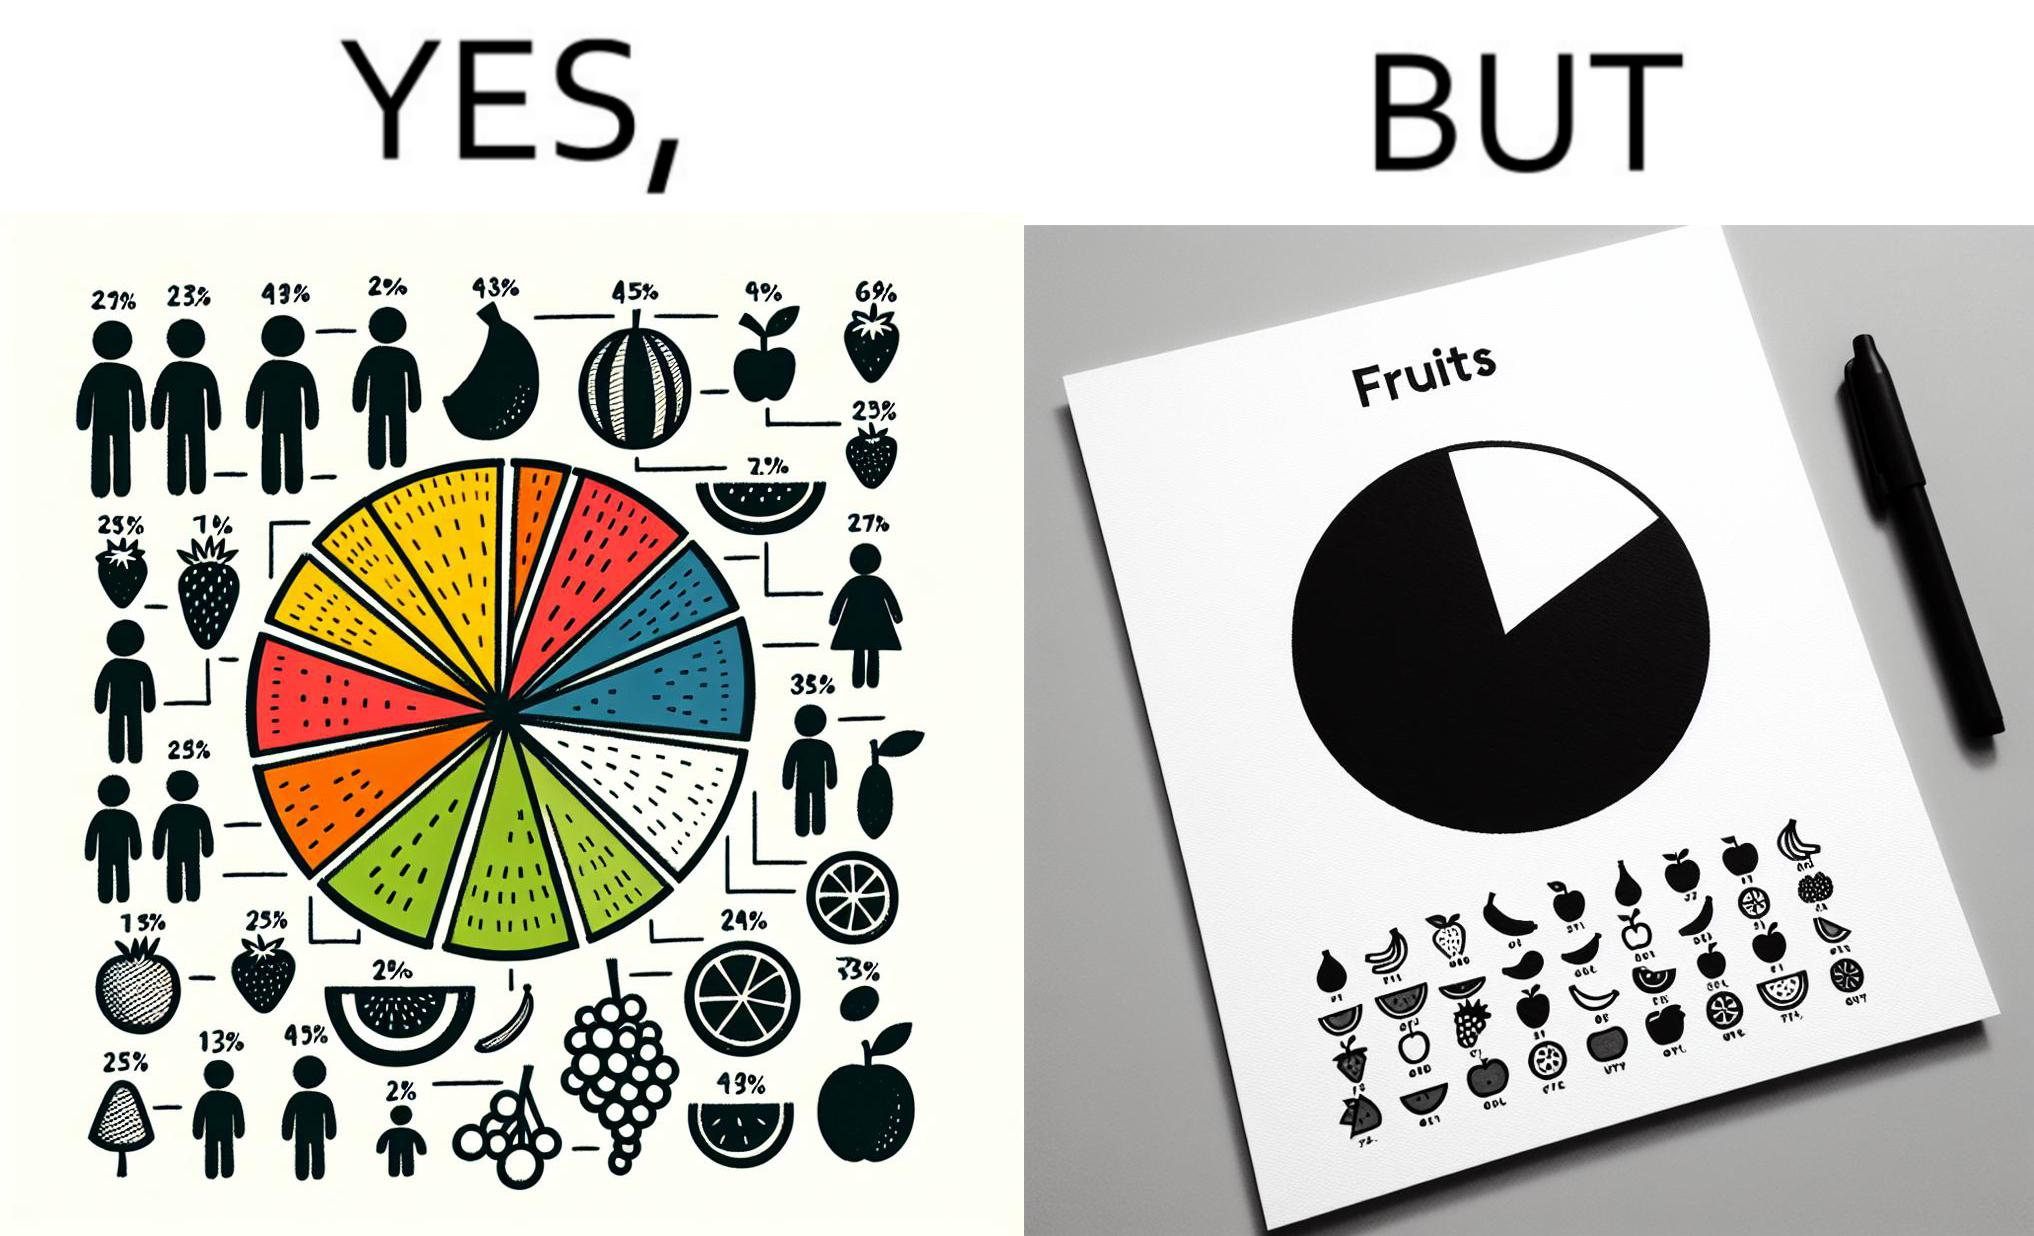Describe what you see in the left and right parts of this image. In the left part of the image: A colorful pie chart titled "Fruits", with different distributions of various fruits like bananas, strawberries, grapes, apples, watermelon, oranges and lemons. In the right part of the image: A BLACK and WHITE greyscale printout of a pie chart titled "Fruits". The pie chart is just one circle with no divisions, but there is a key beside it that mentions various fruits like bananas, strawberries, grapes, apples, watermelon, oranges and lemons. 